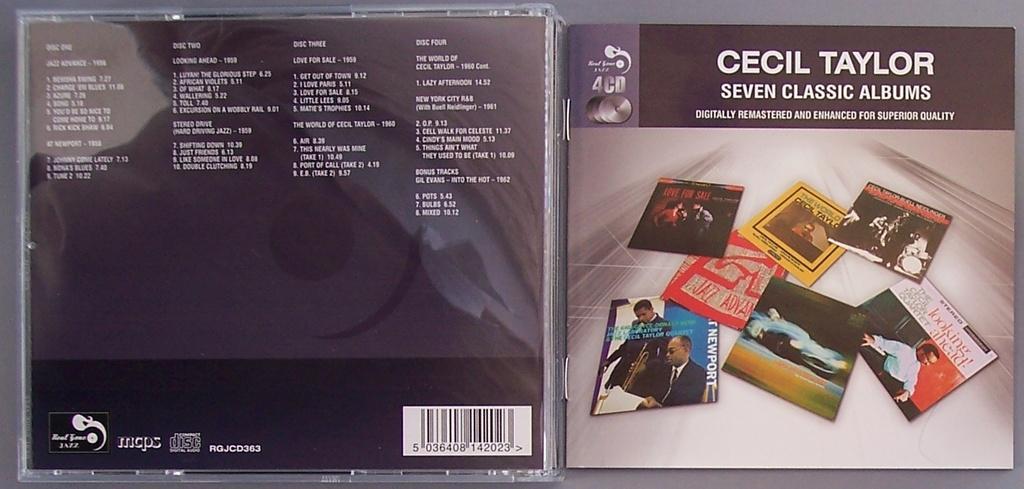Who is the artist?
Give a very brief answer. Cecil taylor. How many classic albums are there?
Offer a terse response. Seven. 